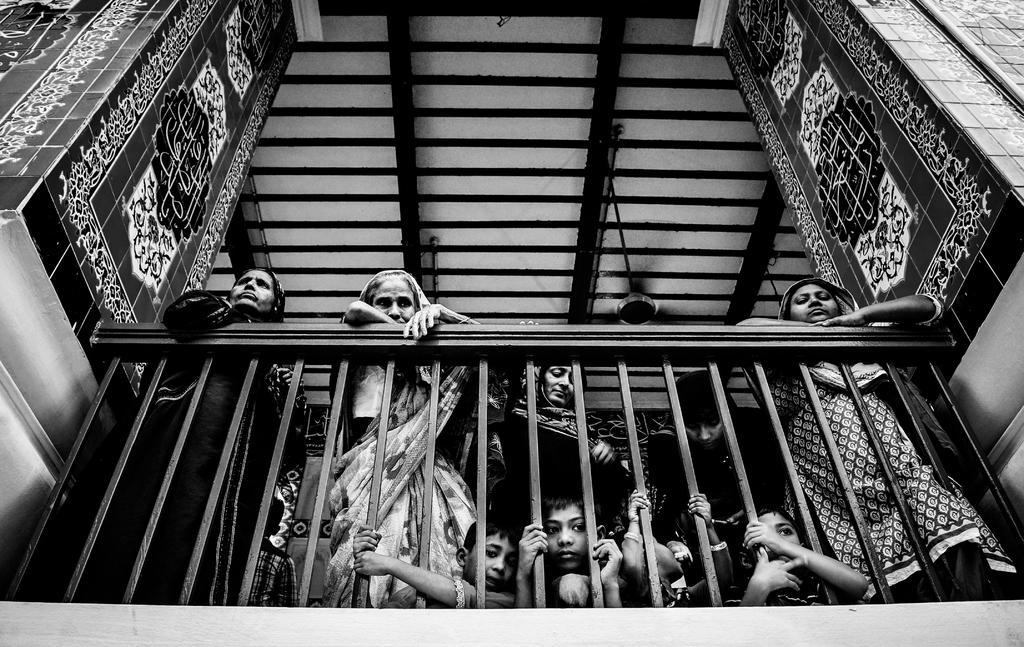What are the people in the image doing? The people in the image are standing near a railing. What architectural features can be seen in the image? There are two pillars in the image. What is attached to the ceiling in the image? There is a fan attached to the ceiling in the image. How many clocks can be seen hanging on the wall in the image? There are no clocks visible in the image. What type of sack is being used by the people in the image? There is no sack present in the image. 